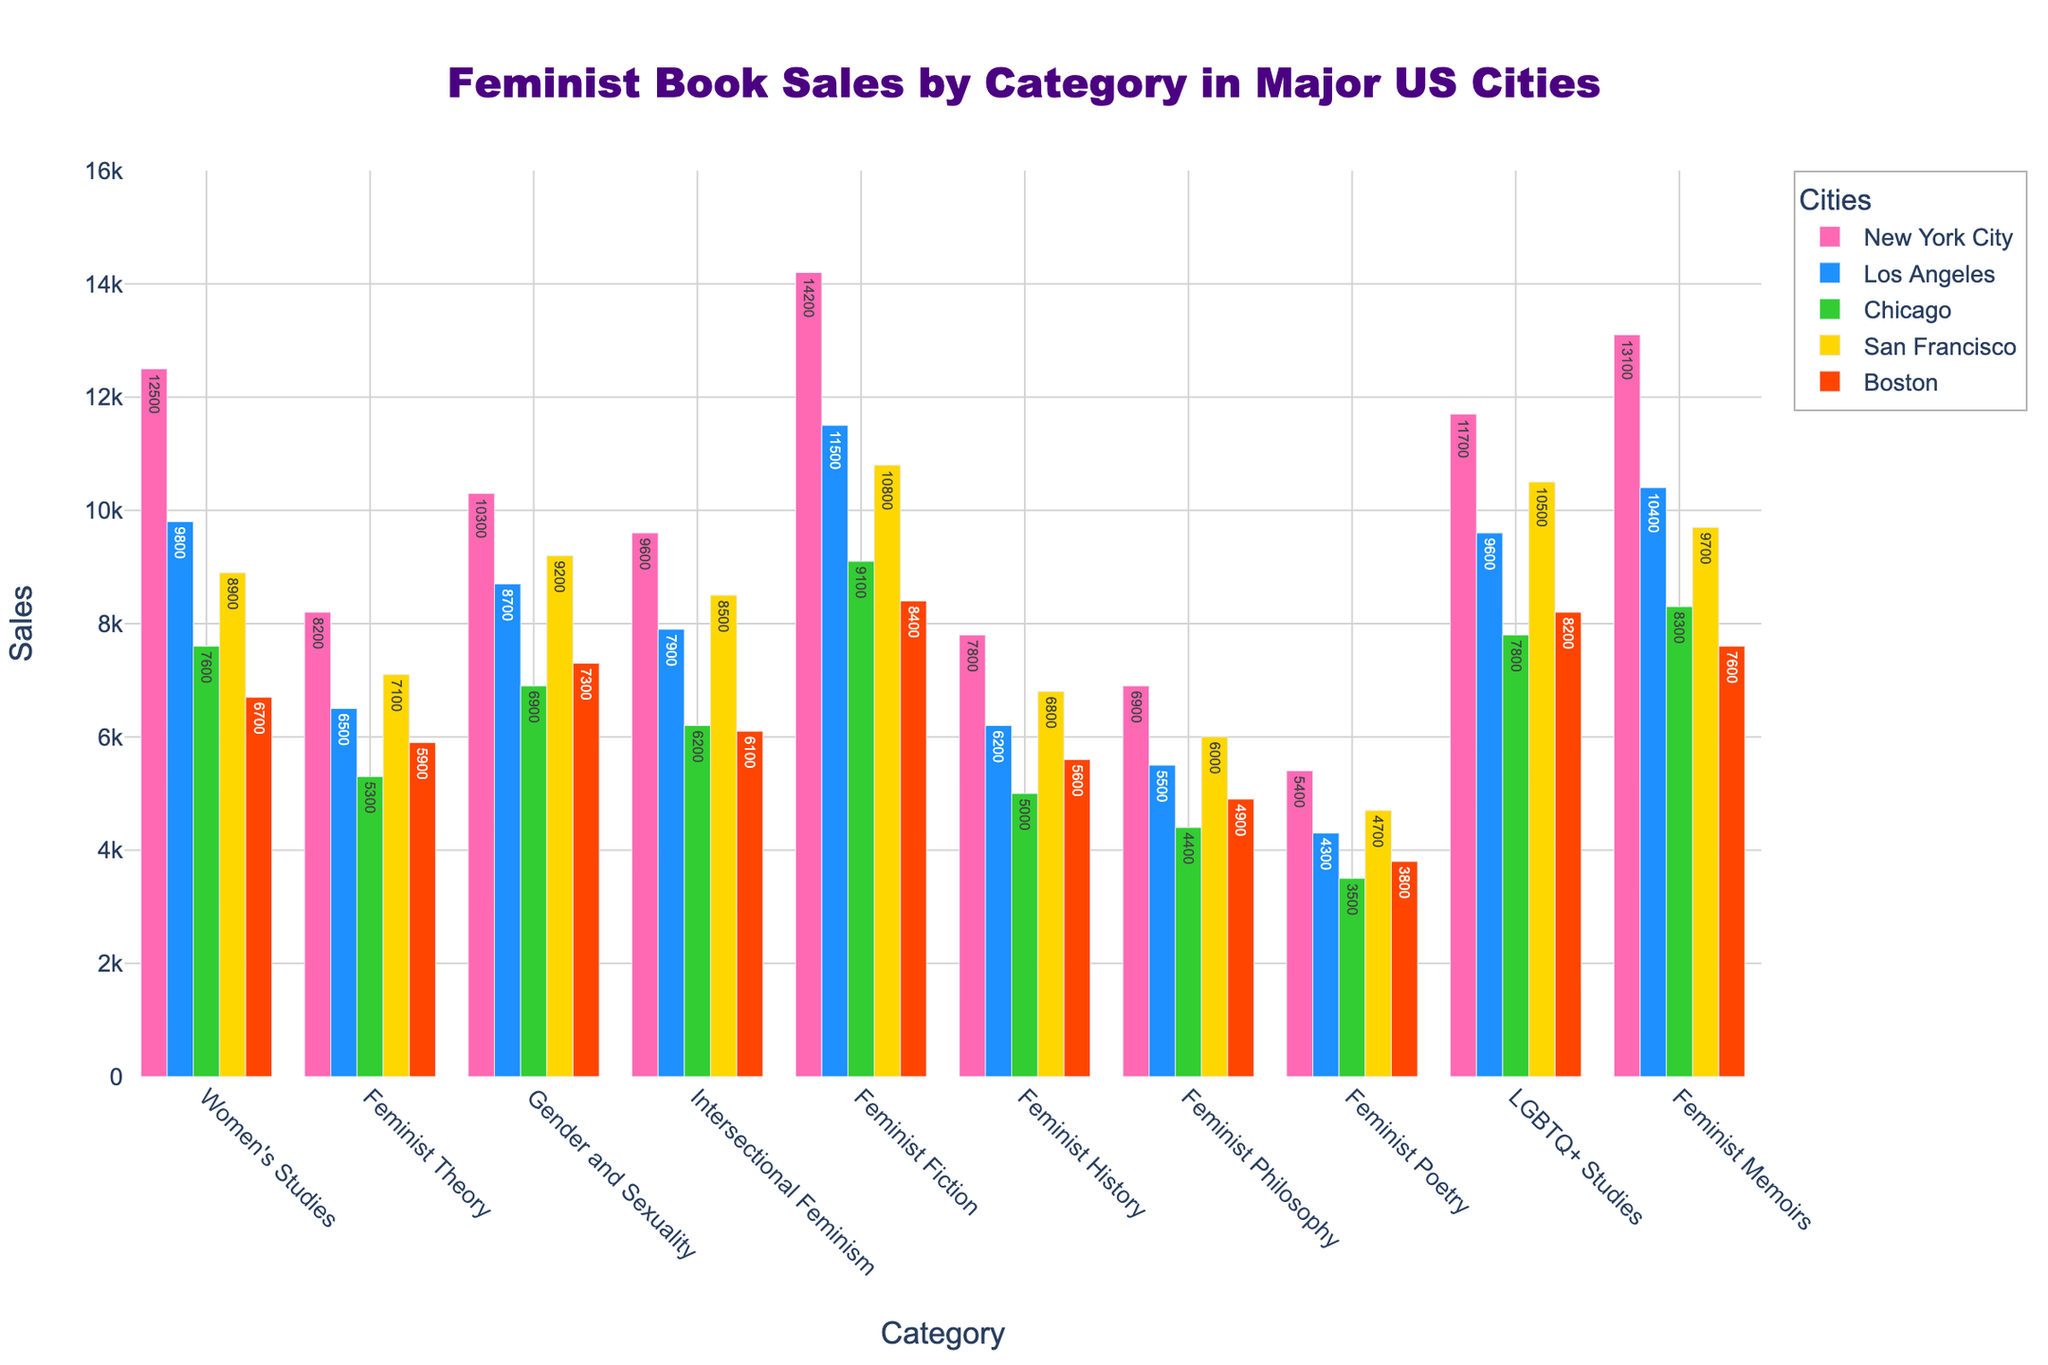what is the total sales of "Feminist Fiction" across all cities? First, find the sales of "Feminist Fiction" in each city: New York City (14200), Los Angeles (11500), Chicago (9100), San Francisco (10800), and Boston (8400). Then sum these values: 14200 + 11500 + 9100 + 10800 + 8400 = 54000.
Answer: 54000 Which city has the highest sales in the "Women's Studies" category? Identify the sales of "Women's Studies" in each city: New York City (12500), Los Angeles (9800), Chicago (7600), San Francisco (8900), and Boston (6700). The highest value is in New York City with 12500.
Answer: New York City In which category do New York City and Los Angeles have the smallest difference in sales? Calculate the sales difference for each category between New York City and Los Angeles: Women's Studies (12500-9800=2700), Feminist Theory (8200-6500=1700), Gender and Sexuality (10300-8700=1600), Intersectional Feminism (9600-7900=1700), Feminist Fiction (14200-11500=2700), Feminist History (7800-6200=1600), Feminist Philosophy (6900-5500=1400), Feminist Poetry (5400-4300=1100), LGBTQ+ Studies (11700-9600=2100), Feminist Memoirs (13100-10400=2700). The smallest difference is in Feminist Poetry (1100).
Answer: Feminist Poetry What is the average sales of "LGBTQ+ Studies" across all cities? Find the sales of "LGBTQ+ Studies" in each city: New York City (11700), Los Angeles (9600), Chicago (7800), San Francisco (10500), and Boston (8200). Sum these values: 11700 + 9600 + 7800 + 10500 + 8200 = 47800. Then, divide by the number of cities: 47800 / 5 = 9560.
Answer: 9560 Which category had the lowest sales in Chicago? Identify the sales values of each category in Chicago and pick the smallest one: Women's Studies (7600), Feminist Theory (5300), Gender and Sexuality (6900), Intersectional Feminism (6200), Feminist Fiction (9100), Feminist History (5000), Feminist Philosophy (4400), Feminist Poetry (3500), LGBTQ+ Studies (7800), Feminist Memoirs (8300). The lowest value is in Feminist Poetry with 3500.
Answer: Feminist Poetry Which city sold the most "Gender and Sexuality" books, and which city sold the least? Find the sales of "Gender and Sexuality" in each city: New York City (10300), Los Angeles (8700), Chicago (6900), San Francisco (9200), and Boston (7300). The city with the most sales is New York City (10300), and the city with the least sales is Chicago (6900).
Answer: New York City, Chicago By how much do "Feminist Memoirs" sales in New York City exceed those in Boston? Find the sales of "Feminist Memoirs" in New York City (13100) and Boston (7600). The difference is 13100 - 7600 = 5500.
Answer: 5500 What is the total sales across all categories in San Francisco? Sum the sales for all categories in San Francisco: Women's Studies (8900), Feminist Theory (7100), Gender and Sexuality (9200), Intersectional Feminism (8500), Feminist Fiction (10800), Feminist History (6800), Feminist Philosophy (6000), Feminist Poetry (4700), LGBTQ+ Studies (10500), Feminist Memoirs (9700). The total is 8900 + 7100 + 9200 + 8500 + 10800 + 6800 + 6000 + 4700 + 10500 + 9700 = 82700.
Answer: 82700 Which category has the closest sales figures between New York City and Chicago? Calculate the sales difference for each category between New York City and Chicago: Women's Studies (12500-7600=4900), Feminist Theory (8200-5300=2900), Gender and Sexuality (10300-6900=3400), Intersectional Feminism (9600-6200=3400), Feminist Fiction (14200-9100=5100), Feminist History (7800-5000=2800), Feminist Philosophy (6900-4400=2500), Feminist Poetry (5400-3500=1900), LGBTQ+ Studies (11700-7800=3900), Feminist Memoirs (13100-8300=4800). The closest difference is in Feminist Poetry (1900).
Answer: Feminist Poetry 